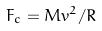Convert formula to latex. <formula><loc_0><loc_0><loc_500><loc_500>F _ { c } = M v ^ { 2 } / R</formula> 